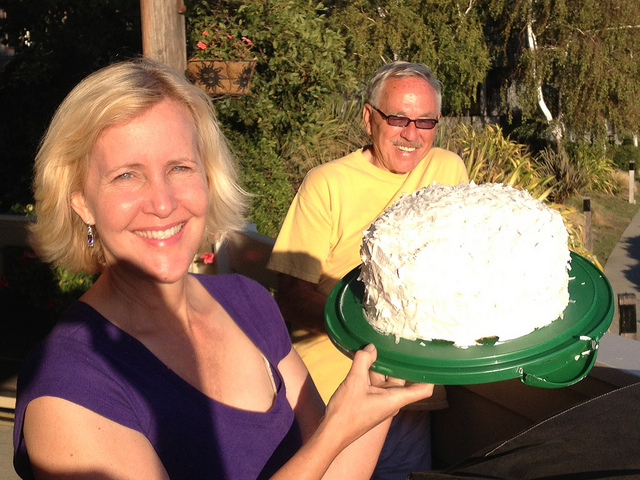How many people are in the picture? There are two people in the picture, a woman in the foreground holding a large cake and a man in the background smiling. 